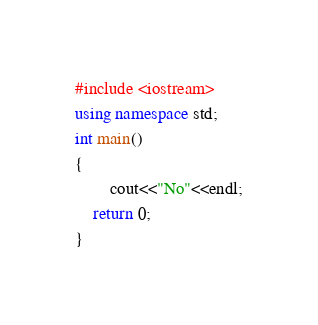<code> <loc_0><loc_0><loc_500><loc_500><_C++_>#include <iostream>
using namespace std;
int main()
{
		cout<<"No"<<endl;
	return 0;
}
</code> 